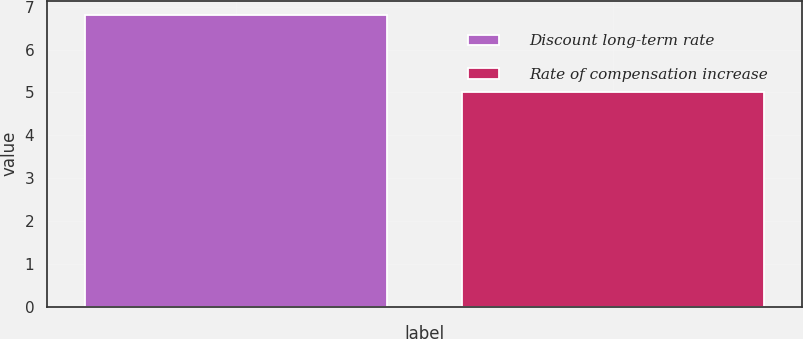Convert chart to OTSL. <chart><loc_0><loc_0><loc_500><loc_500><bar_chart><fcel>Discount long-term rate<fcel>Rate of compensation increase<nl><fcel>6.8<fcel>5<nl></chart> 